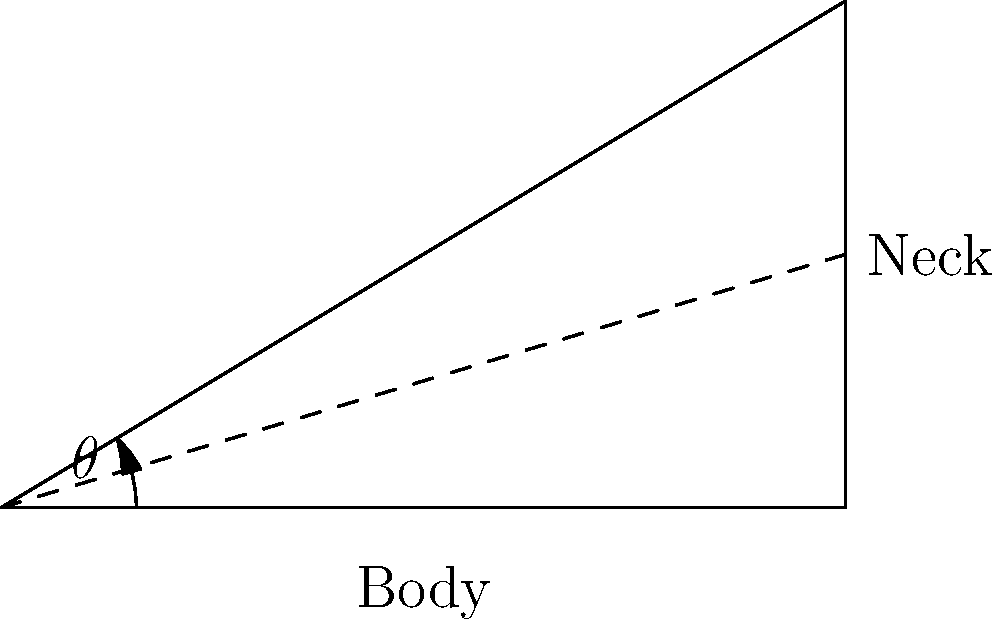As a music educator with experience in guitar design, you're tasked with determining the optimal angle for a guitar neck relative to its body. If the neck extends 5 inches horizontally from the body and rises 3 inches vertically, what is the angle $\theta$ (in degrees) between the guitar body and the neck? To solve this problem, we'll use basic trigonometry:

1. The guitar neck forms a right triangle with the body and the vertical rise.
2. We know the adjacent side (horizontal extension) is 5 inches and the opposite side (vertical rise) is 3 inches.
3. To find the angle $\theta$, we'll use the arctangent function:

   $$\theta = \arctan(\frac{\text{opposite}}{\text{adjacent}})$$

4. Plugging in our values:

   $$\theta = \arctan(\frac{3}{5})$$

5. Using a calculator or programming language to evaluate this:

   $$\theta \approx 30.96^\circ$$

6. Rounding to the nearest degree:

   $$\theta \approx 31^\circ$$

This angle of approximately 31° between the guitar body and neck is typically considered within the range for optimal playability, balancing factors like string tension and player comfort.
Answer: 31° 